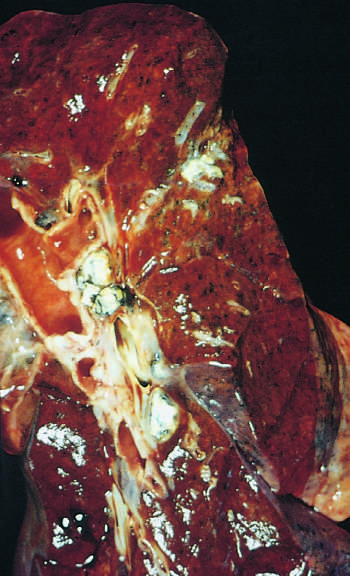s scarring under the pleura in the lower part of the upper lobe?
Answer the question using a single word or phrase. No 